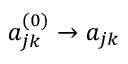Convert formula to latex. <formula><loc_0><loc_0><loc_500><loc_500>{ a _ { j k } ^ { ( 0 ) } } \to a _ { j k }</formula> 